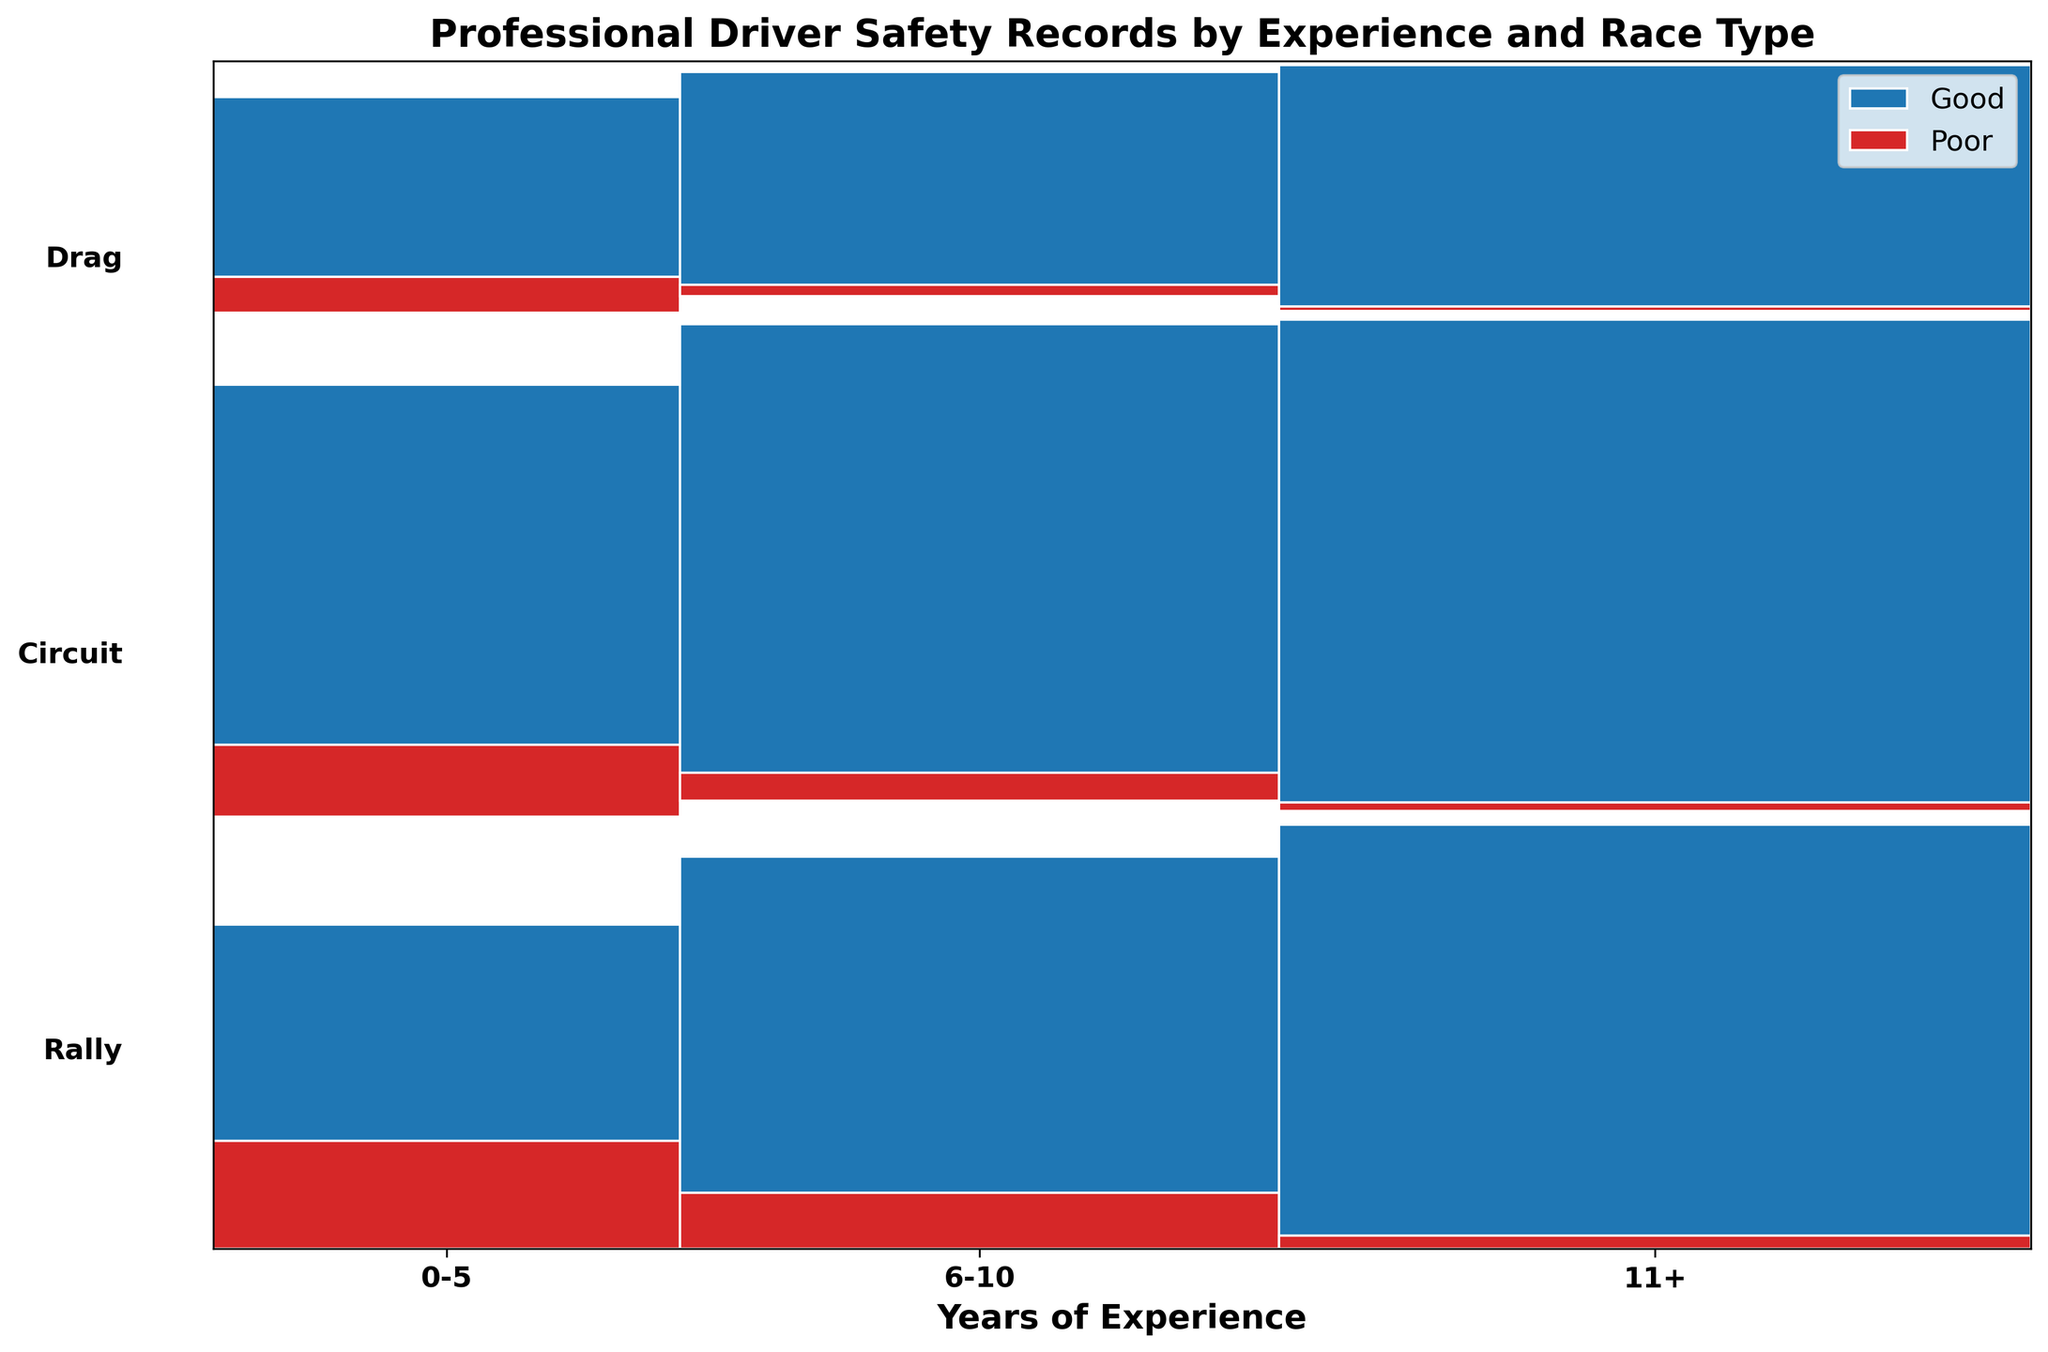What's the title of the figure? The title is found at the top of the figure and acts as a summary of what the plot represents. This figure's title should be read directly from there.
Answer: Professional Driver Safety Records by Experience and Race Type What do the blue and red colors represent in the plot? The legend in the upper right corner indicates what the colors represent. By checking the legend, the blue color represents 'Good' safety ratings and the red color represents 'Poor' safety ratings.
Answer: Good and Poor safety ratings Which type of race has the highest proportion of 'Good' ratings for drivers with 0-5 years of experience? To answer this, look at the segments corresponding to '0-5' years of experience for each race type (Rally, Circuit, Drag) and compare the portion of blue color within each race type. The one with the most substantial blue portion indicates the highest proportion of 'Good' ratings. In this case, Circuit has the highest blue portion.
Answer: Circuit How does the proportion of 'Poor' ratings in Rally races compare between drivers with 0-5 years and those with 11+ years of experience? Compare the segments for Rally races in both '0-5' and '11+' years of experience categories. Note the red portion (Poor ratings) in each segment. Drivers with 0-5 years have a larger red portion compared to those with 11+ years of experience.
Answer: Higher for 0-5 years In which race type do drivers with 6-10 years of experience have the highest count of 'Good' ratings? Examine the '6-10 years' section for each race type (Rally, Circuit, Drag) and identify the race type with the largest blue rectangle (representing 'Good' ratings). Circuit has the largest blue rectangle.
Answer: Circuit What's the total number of drivers with 11+ years of experience participating in Drag races? In the '11+' years category, sum the counts for both 'Good' and 'Poor' ratings in Drag races. This is done by adding 55 ('Good') and 1 ('Poor').
Answer: 56 Which experience level has the smallest portion of 'Poor' ratings across all race types? Look across all 'Years of Experience' categories (0-5, 6-10, 11+), comparing the combined red portions. '11+' years of experience has the smallest portion of 'Poor' ratings.
Answer: 11+ Which experience group has the most drivers participating in Rally races? Compare the widths of the Rally segments within each experience group. The group with the widest Rally segment indicates the most drivers. '11+' years of experience has the widest Rally segment.
Answer: 11+ In Drag races, how does the number of 'Good' ratings compare between drivers with 0-5 years and 6-10 years of experience? Compare the number within the Drag segments for 'Good' ratings between the two groups. For 0-5 years, the 'Good' rating is 30, and for 6-10 years it's 40. Thus, drivers with 6-10 years have more 'Good' ratings.
Answer: More for 6-10 years 